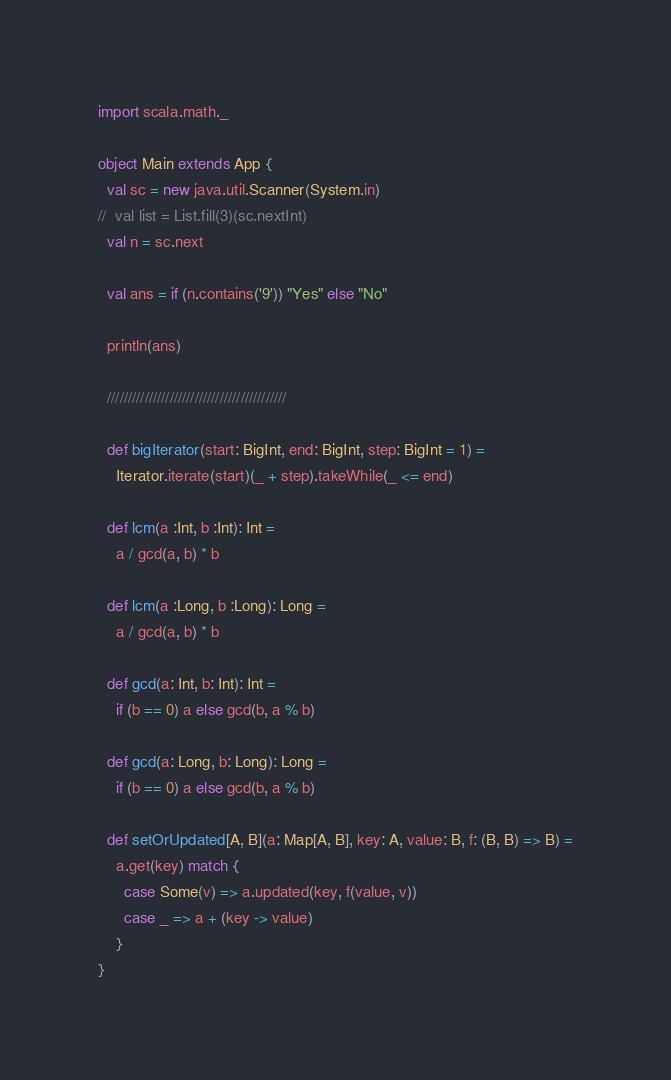<code> <loc_0><loc_0><loc_500><loc_500><_Scala_>import scala.math._

object Main extends App {
  val sc = new java.util.Scanner(System.in)
//  val list = List.fill(3)(sc.nextInt)
  val n = sc.next

  val ans = if (n.contains('9')) "Yes" else "No"

  println(ans)

  ///////////////////////////////////////////

  def bigIterator(start: BigInt, end: BigInt, step: BigInt = 1) =
    Iterator.iterate(start)(_ + step).takeWhile(_ <= end)

  def lcm(a :Int, b :Int): Int =
    a / gcd(a, b) * b

  def lcm(a :Long, b :Long): Long =
    a / gcd(a, b) * b

  def gcd(a: Int, b: Int): Int =
    if (b == 0) a else gcd(b, a % b)

  def gcd(a: Long, b: Long): Long =
    if (b == 0) a else gcd(b, a % b)

  def setOrUpdated[A, B](a: Map[A, B], key: A, value: B, f: (B, B) => B) =
    a.get(key) match {
      case Some(v) => a.updated(key, f(value, v))
      case _ => a + (key -> value)
    }
}</code> 